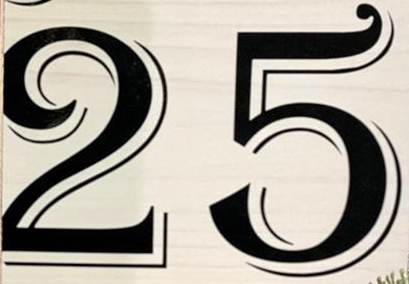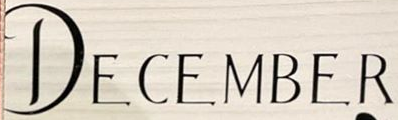Transcribe the words shown in these images in order, separated by a semicolon. 25; DECEMBER 